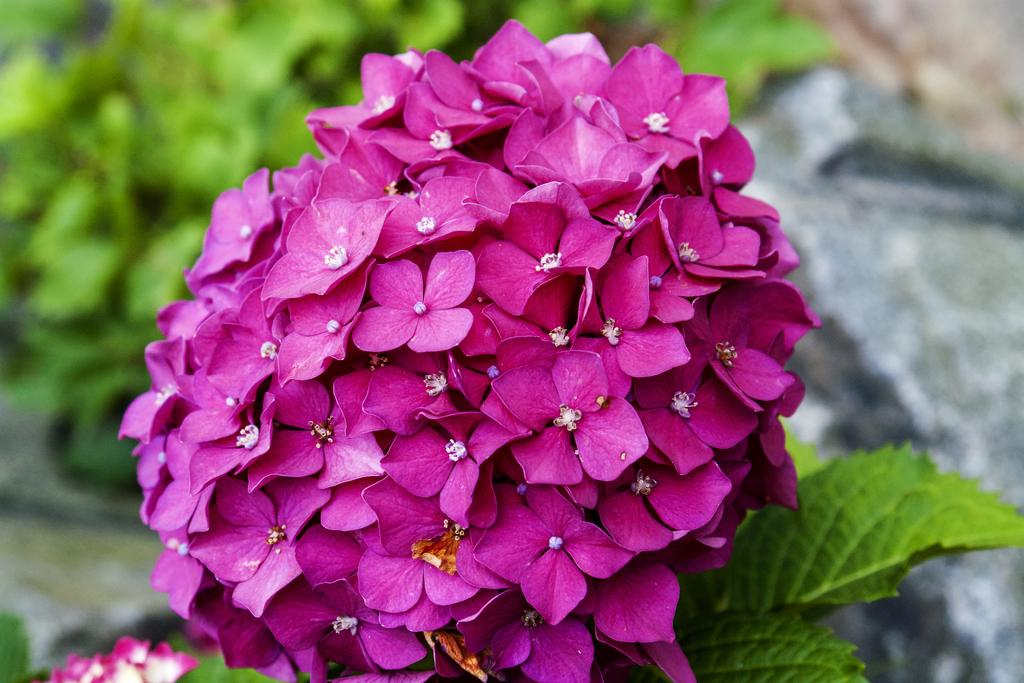What type of plants can be seen in the image? There are flowers and leaves in the image. Can you describe the background of the image? The background of the image is blurred. Is there a crown visible on the flowers in the image? No, there is no crown present in the image. Is there a throne visible in the image? No, there is no throne present in the image. 